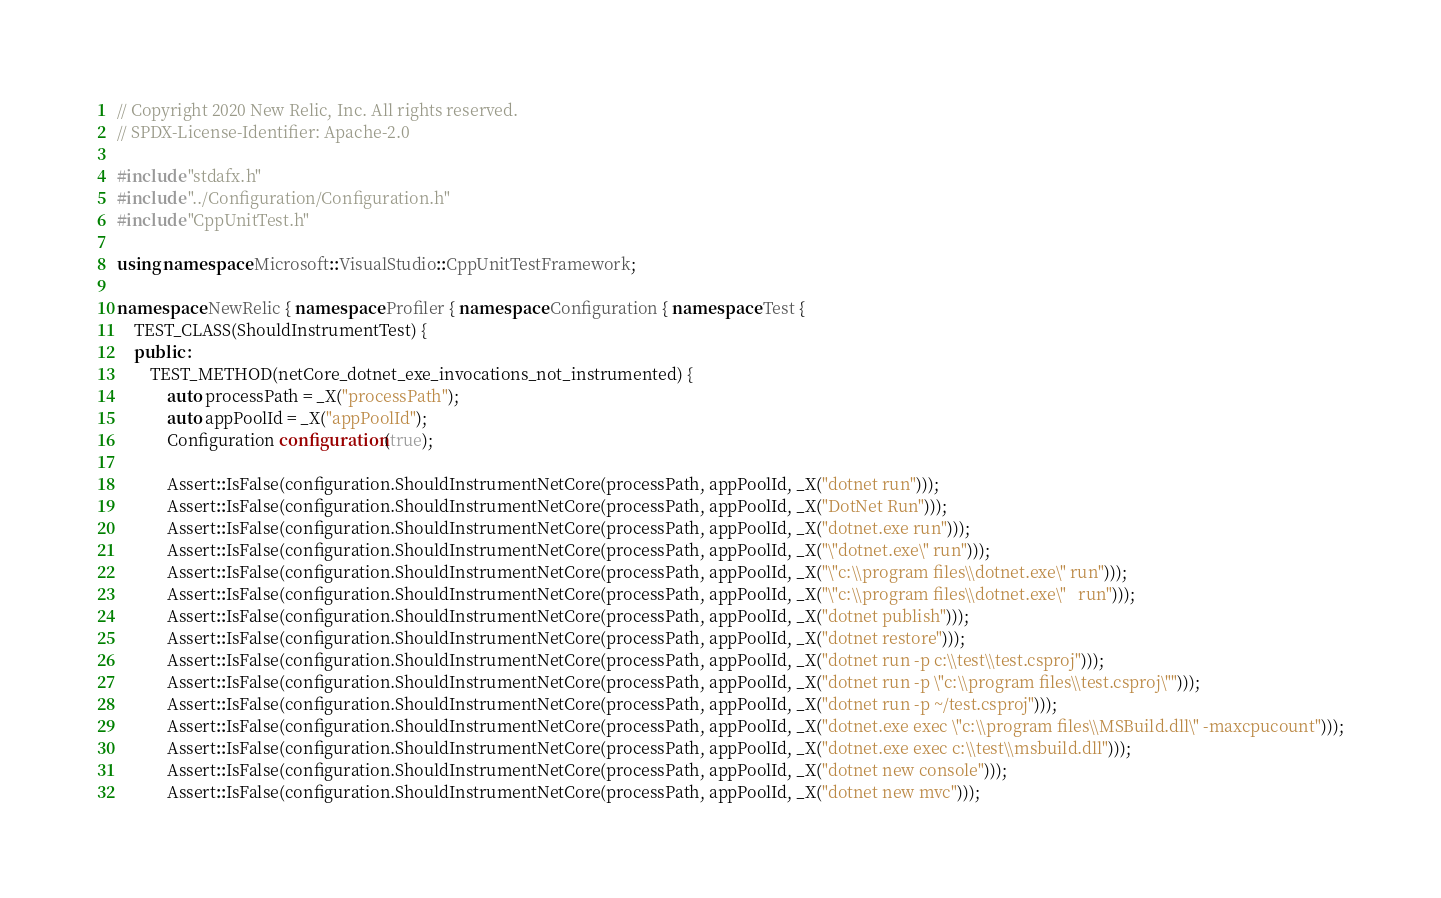<code> <loc_0><loc_0><loc_500><loc_500><_C++_>// Copyright 2020 New Relic, Inc. All rights reserved.
// SPDX-License-Identifier: Apache-2.0

#include "stdafx.h"
#include "../Configuration/Configuration.h"
#include "CppUnitTest.h"

using namespace Microsoft::VisualStudio::CppUnitTestFramework;

namespace NewRelic { namespace Profiler { namespace Configuration { namespace Test {
    TEST_CLASS(ShouldInstrumentTest) {
    public :
        TEST_METHOD(netCore_dotnet_exe_invocations_not_instrumented) {
            auto processPath = _X("processPath");
            auto appPoolId = _X("appPoolId");
            Configuration configuration(true);

            Assert::IsFalse(configuration.ShouldInstrumentNetCore(processPath, appPoolId, _X("dotnet run")));
            Assert::IsFalse(configuration.ShouldInstrumentNetCore(processPath, appPoolId, _X("DotNet Run")));
            Assert::IsFalse(configuration.ShouldInstrumentNetCore(processPath, appPoolId, _X("dotnet.exe run")));
            Assert::IsFalse(configuration.ShouldInstrumentNetCore(processPath, appPoolId, _X("\"dotnet.exe\" run")));
            Assert::IsFalse(configuration.ShouldInstrumentNetCore(processPath, appPoolId, _X("\"c:\\program files\\dotnet.exe\" run")));
            Assert::IsFalse(configuration.ShouldInstrumentNetCore(processPath, appPoolId, _X("\"c:\\program files\\dotnet.exe\"   run")));
            Assert::IsFalse(configuration.ShouldInstrumentNetCore(processPath, appPoolId, _X("dotnet publish")));
            Assert::IsFalse(configuration.ShouldInstrumentNetCore(processPath, appPoolId, _X("dotnet restore")));
            Assert::IsFalse(configuration.ShouldInstrumentNetCore(processPath, appPoolId, _X("dotnet run -p c:\\test\\test.csproj")));
            Assert::IsFalse(configuration.ShouldInstrumentNetCore(processPath, appPoolId, _X("dotnet run -p \"c:\\program files\\test.csproj\"")));
            Assert::IsFalse(configuration.ShouldInstrumentNetCore(processPath, appPoolId, _X("dotnet run -p ~/test.csproj")));
            Assert::IsFalse(configuration.ShouldInstrumentNetCore(processPath, appPoolId, _X("dotnet.exe exec \"c:\\program files\\MSBuild.dll\" -maxcpucount")));
            Assert::IsFalse(configuration.ShouldInstrumentNetCore(processPath, appPoolId, _X("dotnet.exe exec c:\\test\\msbuild.dll")));
            Assert::IsFalse(configuration.ShouldInstrumentNetCore(processPath, appPoolId, _X("dotnet new console")));
            Assert::IsFalse(configuration.ShouldInstrumentNetCore(processPath, appPoolId, _X("dotnet new mvc")));</code> 